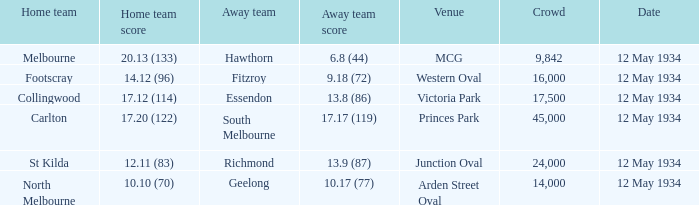What place had an Away team get a score of 10.17 (77)? Arden Street Oval. Write the full table. {'header': ['Home team', 'Home team score', 'Away team', 'Away team score', 'Venue', 'Crowd', 'Date'], 'rows': [['Melbourne', '20.13 (133)', 'Hawthorn', '6.8 (44)', 'MCG', '9,842', '12 May 1934'], ['Footscray', '14.12 (96)', 'Fitzroy', '9.18 (72)', 'Western Oval', '16,000', '12 May 1934'], ['Collingwood', '17.12 (114)', 'Essendon', '13.8 (86)', 'Victoria Park', '17,500', '12 May 1934'], ['Carlton', '17.20 (122)', 'South Melbourne', '17.17 (119)', 'Princes Park', '45,000', '12 May 1934'], ['St Kilda', '12.11 (83)', 'Richmond', '13.9 (87)', 'Junction Oval', '24,000', '12 May 1934'], ['North Melbourne', '10.10 (70)', 'Geelong', '10.17 (77)', 'Arden Street Oval', '14,000', '12 May 1934']]} 